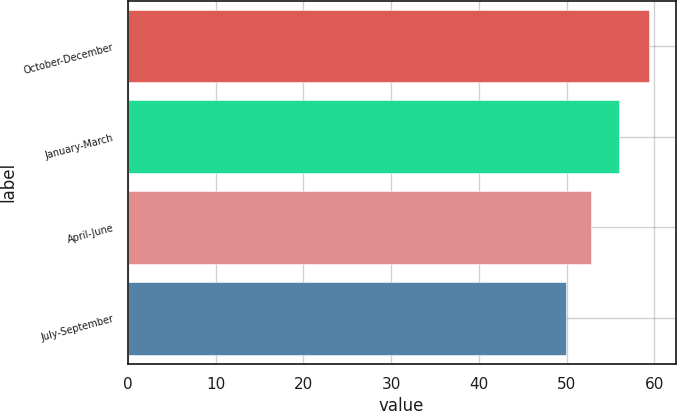Convert chart to OTSL. <chart><loc_0><loc_0><loc_500><loc_500><bar_chart><fcel>October-December<fcel>January-March<fcel>April-June<fcel>July-September<nl><fcel>59.43<fcel>55.91<fcel>52.76<fcel>49.96<nl></chart> 